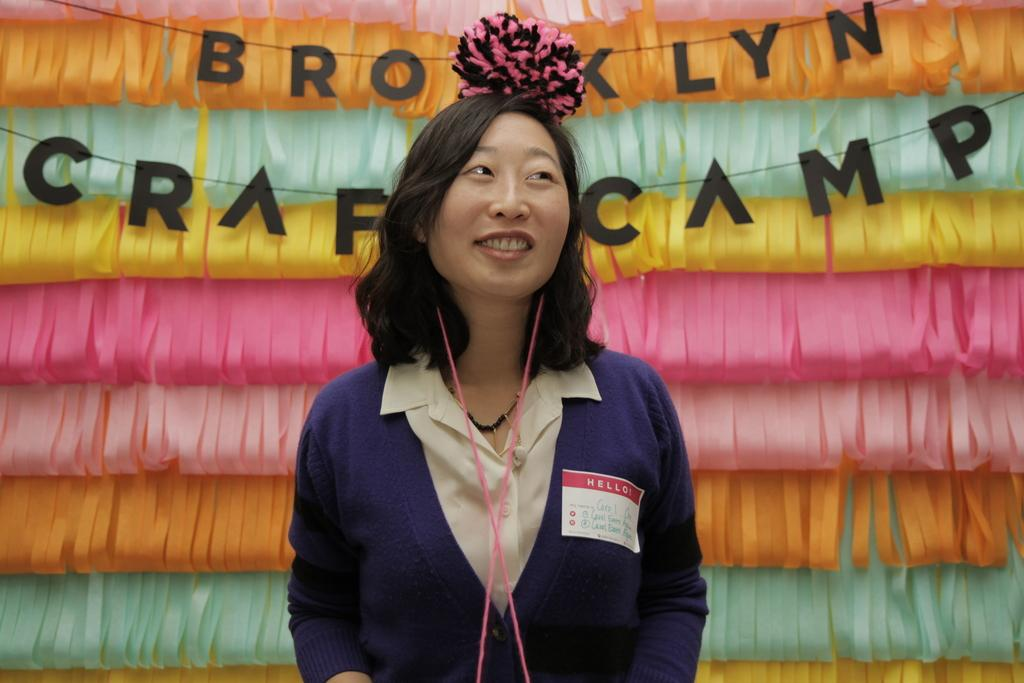Who or what is the main subject in the image? There is a person in the image. What is the person's facial expression? The person has a smile on her face. What can be seen behind the person? There are decorative ribbons behind the person. What else is present in the image? There are letters tied to a wire in the image. What type of liquid is being served with the fork in the image? There is no liquid or fork present in the image. 